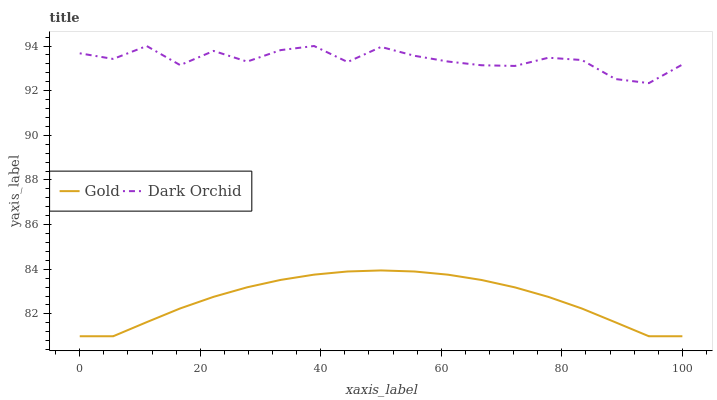Does Gold have the maximum area under the curve?
Answer yes or no. No. Is Gold the roughest?
Answer yes or no. No. Does Gold have the highest value?
Answer yes or no. No. Is Gold less than Dark Orchid?
Answer yes or no. Yes. Is Dark Orchid greater than Gold?
Answer yes or no. Yes. Does Gold intersect Dark Orchid?
Answer yes or no. No. 